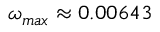Convert formula to latex. <formula><loc_0><loc_0><loc_500><loc_500>\omega _ { \max } \approx 0 . 0 0 6 4 3</formula> 